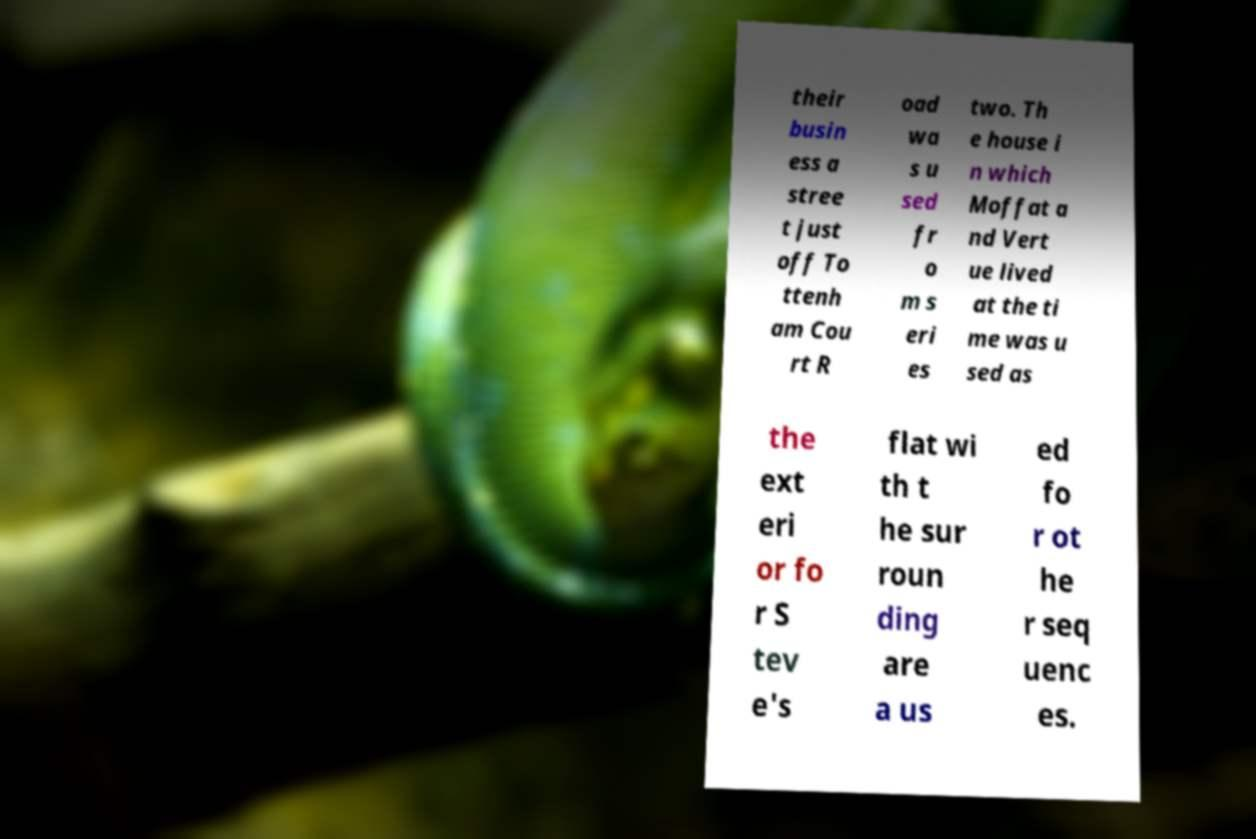Please identify and transcribe the text found in this image. their busin ess a stree t just off To ttenh am Cou rt R oad wa s u sed fr o m s eri es two. Th e house i n which Moffat a nd Vert ue lived at the ti me was u sed as the ext eri or fo r S tev e's flat wi th t he sur roun ding are a us ed fo r ot he r seq uenc es. 